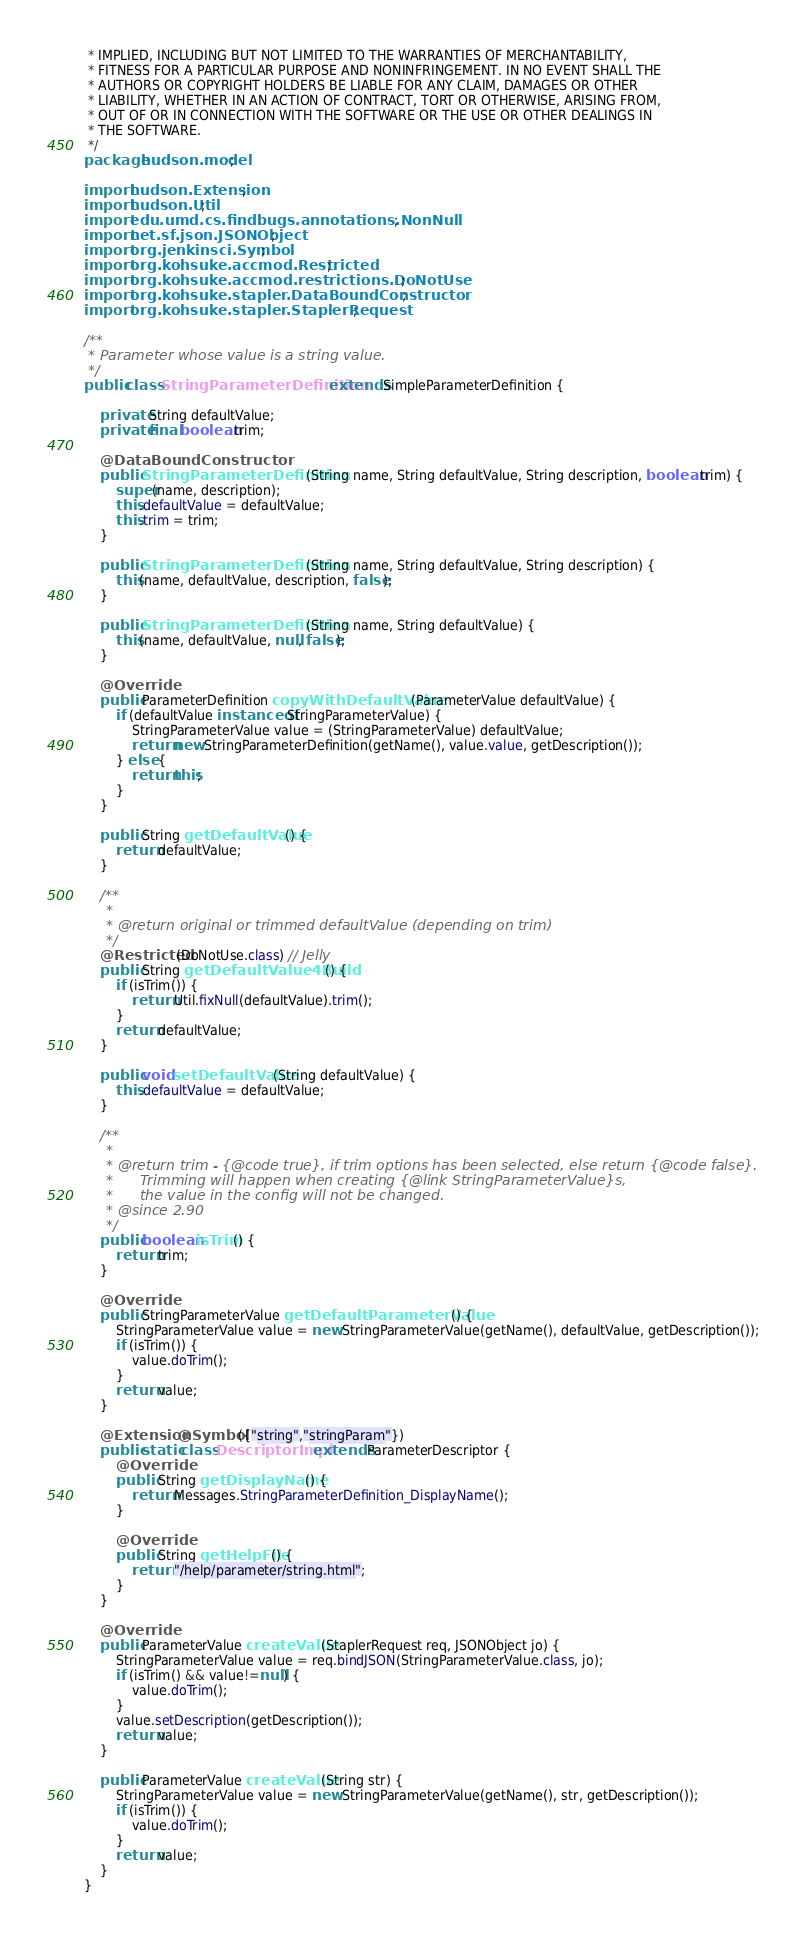Convert code to text. <code><loc_0><loc_0><loc_500><loc_500><_Java_> * IMPLIED, INCLUDING BUT NOT LIMITED TO THE WARRANTIES OF MERCHANTABILITY,
 * FITNESS FOR A PARTICULAR PURPOSE AND NONINFRINGEMENT. IN NO EVENT SHALL THE
 * AUTHORS OR COPYRIGHT HOLDERS BE LIABLE FOR ANY CLAIM, DAMAGES OR OTHER
 * LIABILITY, WHETHER IN AN ACTION OF CONTRACT, TORT OR OTHERWISE, ARISING FROM,
 * OUT OF OR IN CONNECTION WITH THE SOFTWARE OR THE USE OR OTHER DEALINGS IN
 * THE SOFTWARE.
 */
package hudson.model;

import hudson.Extension;
import hudson.Util;
import edu.umd.cs.findbugs.annotations.NonNull;
import net.sf.json.JSONObject;
import org.jenkinsci.Symbol;
import org.kohsuke.accmod.Restricted;
import org.kohsuke.accmod.restrictions.DoNotUse;
import org.kohsuke.stapler.DataBoundConstructor;
import org.kohsuke.stapler.StaplerRequest;

/**
 * Parameter whose value is a string value.
 */
public class StringParameterDefinition extends SimpleParameterDefinition {

    private String defaultValue;
    private final boolean trim;

    @DataBoundConstructor
    public StringParameterDefinition(String name, String defaultValue, String description, boolean trim) {
        super(name, description);
        this.defaultValue = defaultValue;
        this.trim = trim;
    }

    public StringParameterDefinition(String name, String defaultValue, String description) {
        this(name, defaultValue, description, false);
    }
    
    public StringParameterDefinition(String name, String defaultValue) {
        this(name, defaultValue, null, false);
    }

    @Override
    public ParameterDefinition copyWithDefaultValue(ParameterValue defaultValue) {
        if (defaultValue instanceof StringParameterValue) {
            StringParameterValue value = (StringParameterValue) defaultValue;
            return new StringParameterDefinition(getName(), value.value, getDescription());
        } else {
            return this;
        }
    }

    public String getDefaultValue() {
        return defaultValue;
    }

    /**
     * 
     * @return original or trimmed defaultValue (depending on trim)
     */
    @Restricted(DoNotUse.class) // Jelly
    public String getDefaultValue4Build() {
        if (isTrim()) {
            return Util.fixNull(defaultValue).trim();
        }
        return defaultValue;
    }
    
    public void setDefaultValue(String defaultValue) {
        this.defaultValue = defaultValue;
    }

    /**
     * 
     * @return trim - {@code true}, if trim options has been selected, else return {@code false}.
     *      Trimming will happen when creating {@link StringParameterValue}s,
     *      the value in the config will not be changed.
     * @since 2.90
     */
    public boolean isTrim() {
        return trim;
    }
    
    @Override
    public StringParameterValue getDefaultParameterValue() {
        StringParameterValue value = new StringParameterValue(getName(), defaultValue, getDescription());
        if (isTrim()) {
            value.doTrim();
        }
        return value;
    }

    @Extension @Symbol({"string","stringParam"})
    public static class DescriptorImpl extends ParameterDescriptor {
        @Override
        public String getDisplayName() {
            return Messages.StringParameterDefinition_DisplayName();
        }

        @Override
        public String getHelpFile() {
            return "/help/parameter/string.html";
        }
    }

    @Override
    public ParameterValue createValue(StaplerRequest req, JSONObject jo) {
        StringParameterValue value = req.bindJSON(StringParameterValue.class, jo);
        if (isTrim() && value!=null) {
            value.doTrim();
        }
        value.setDescription(getDescription());
        return value;
    }

    public ParameterValue createValue(String str) {
        StringParameterValue value = new StringParameterValue(getName(), str, getDescription());
        if (isTrim()) {
            value.doTrim();
        }
        return value;
    }
}
</code> 